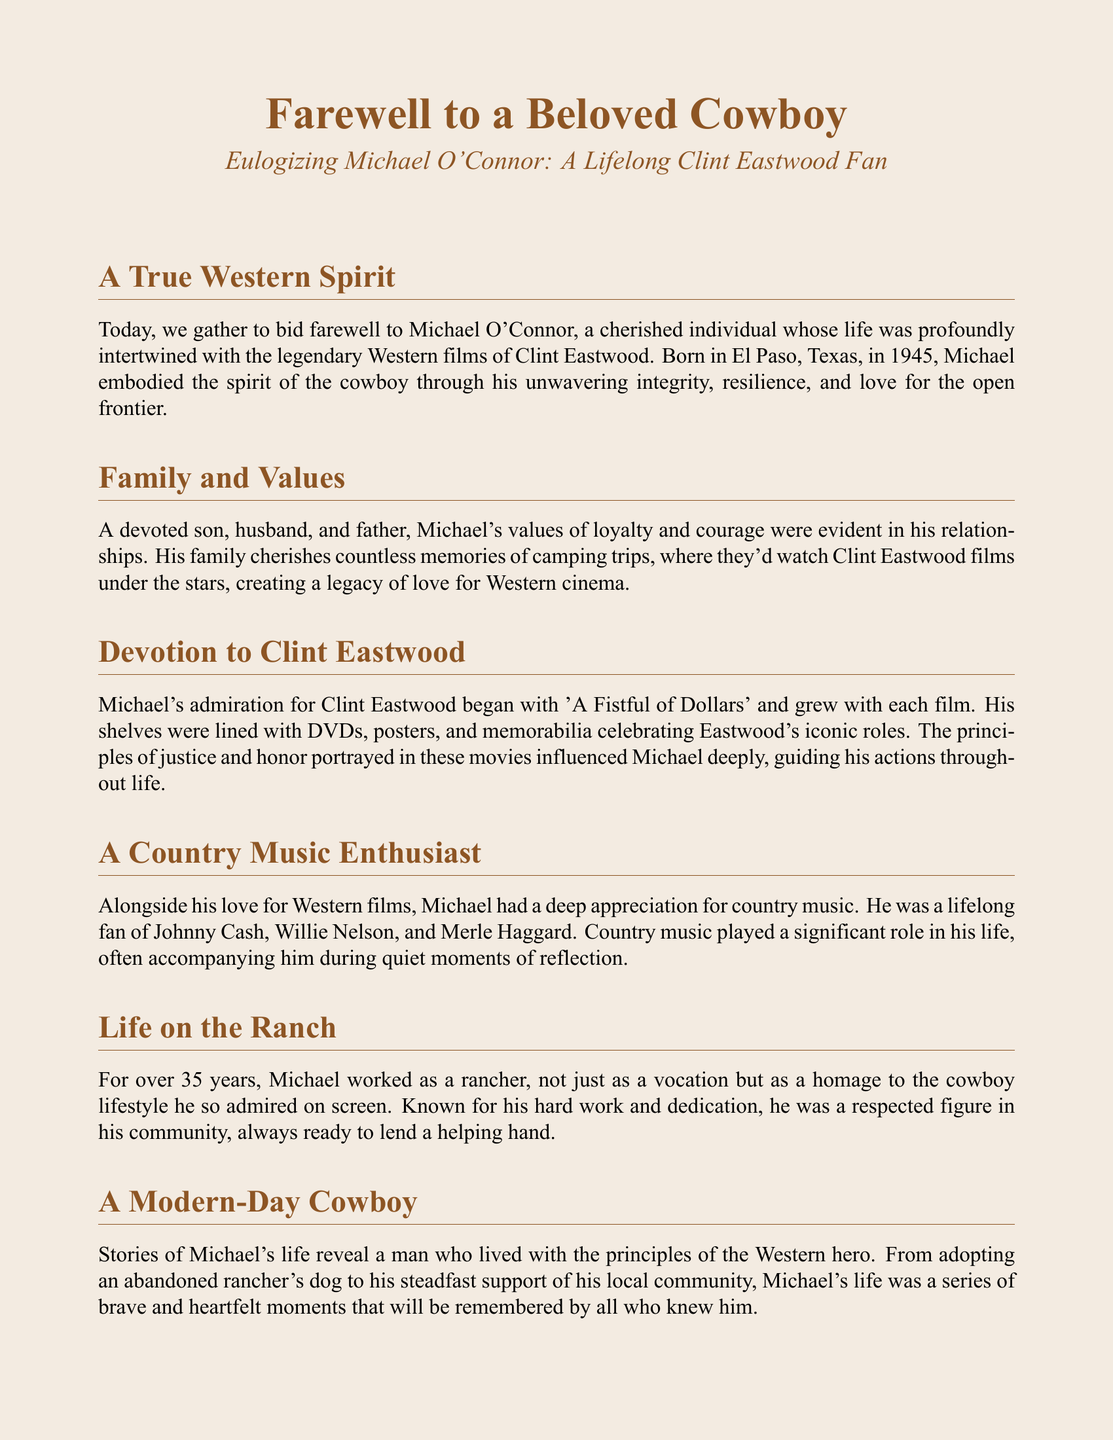What year was Michael O'Connor born? The document states that Michael was born in El Paso, Texas, in 1945.
Answer: 1945 What was Michael's profession for over 35 years? The text mentions that he worked as a rancher, emphasizing his admiration for the cowboy lifestyle.
Answer: Rancher Which Clint Eastwood film sparked Michael's admiration? The eulogy mentions that his admiration for Clint Eastwood began with 'A Fistful of Dollars.'
Answer: A Fistful of Dollars What is one of the key principles Michael lived by? The document discusses the values of loyalty and courage that he displayed in his relationships.
Answer: Loyalty How many children did Michael have? The document mentions that he was a devoted son, husband, and father but does not specify the number of children.
Answer: Not specified What genre of music did Michael appreciate? The text indicates that Michael had a deep appreciation for country music alongside his love for Western films.
Answer: Country music In which community was Michael respected? The eulogy describes him as a respected figure in his local community due to his hard work and dedication.
Answer: Local community What role did country music play in Michael's life? The document states that country music often accompanied him during quiet moments of reflection.
Answer: Reflection What is celebrated in the farewell? The eulogy emphasizes the celebration of Michael's journey through life, mirroring the tales of the Wild West.
Answer: Michael's journey 